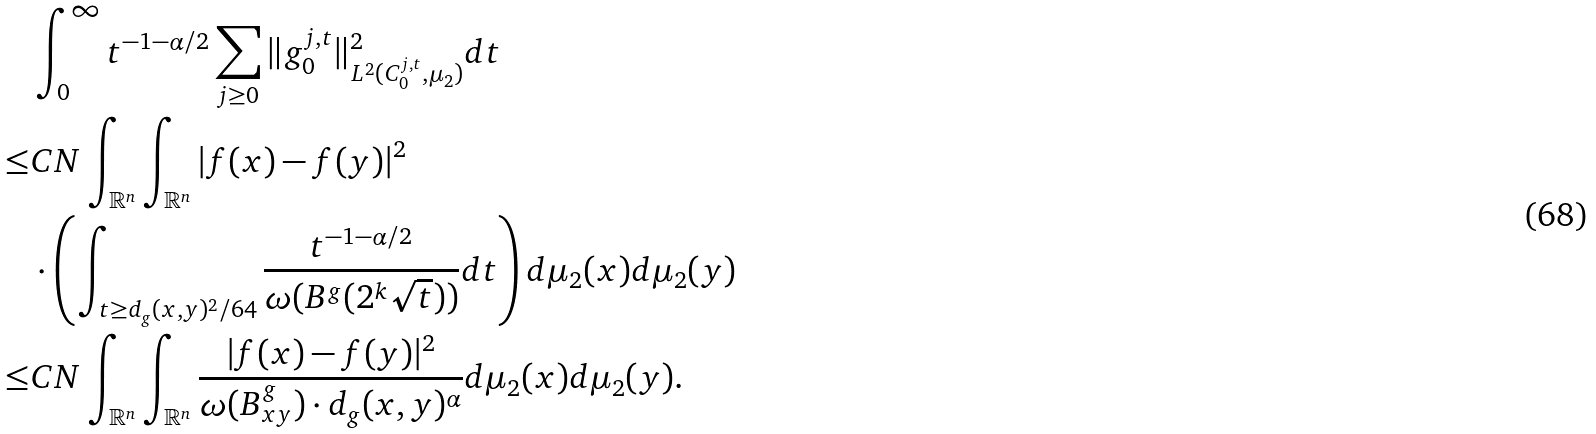<formula> <loc_0><loc_0><loc_500><loc_500>& \int _ { 0 } ^ { \infty } t ^ { - 1 - \alpha / 2 } \sum _ { j \geq 0 } \| g _ { 0 } ^ { j , t } \| ^ { 2 } _ { L ^ { 2 } ( C _ { 0 } ^ { j , t } , \mu _ { 2 } ) } d t \\ \leq & C N \int _ { \mathbb { R } ^ { n } } \int _ { \mathbb { R } ^ { n } } | f ( x ) - f ( y ) | ^ { 2 } \\ & \cdot \left ( \int _ { t \geq d _ { g } ( x , y ) ^ { 2 } / 6 4 } \frac { t ^ { - 1 - \alpha / 2 } } { \omega ( B ^ { g } ( 2 ^ { k } \sqrt { t } ) ) } d t \right ) d \mu _ { 2 } ( x ) d \mu _ { 2 } ( y ) \\ \leq & C N \int _ { \mathbb { R } ^ { n } } \int _ { \mathbb { R } ^ { n } } \frac { | f ( x ) - f ( y ) | ^ { 2 } } { \omega ( B ^ { g } _ { x y } ) \cdot d _ { g } ( x , y ) ^ { \alpha } } d \mu _ { 2 } ( x ) d \mu _ { 2 } ( y ) . \\</formula> 